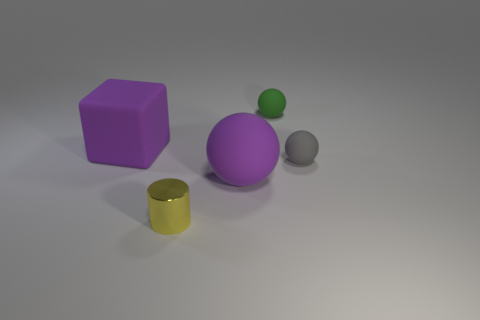Add 3 small green cylinders. How many objects exist? 8 Subtract all spheres. How many objects are left? 2 Subtract all small metal cylinders. Subtract all balls. How many objects are left? 1 Add 2 large blocks. How many large blocks are left? 3 Add 1 big gray things. How many big gray things exist? 1 Subtract 0 cyan cylinders. How many objects are left? 5 